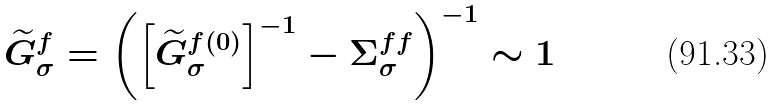<formula> <loc_0><loc_0><loc_500><loc_500>\widetilde { G } ^ { f } _ { \sigma } = \left ( \left [ \widetilde { G } ^ { f ( 0 ) } _ { \sigma } \right ] ^ { - 1 } - \Sigma ^ { f f } _ { \sigma } \right ) ^ { - 1 } \sim 1</formula> 